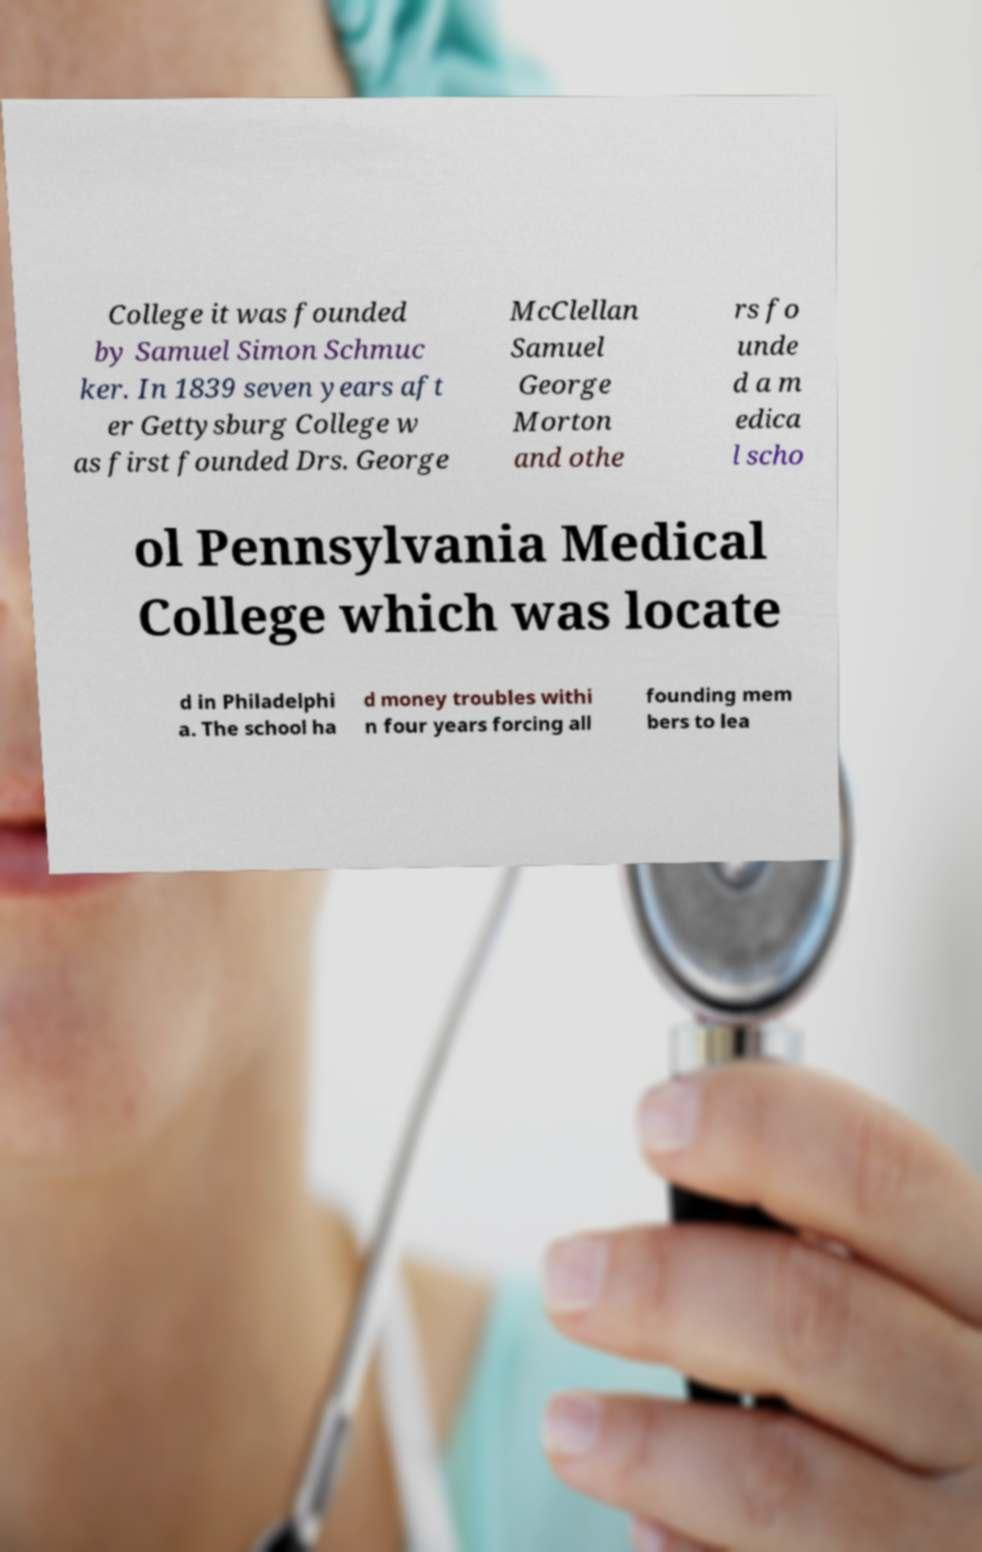Could you extract and type out the text from this image? College it was founded by Samuel Simon Schmuc ker. In 1839 seven years aft er Gettysburg College w as first founded Drs. George McClellan Samuel George Morton and othe rs fo unde d a m edica l scho ol Pennsylvania Medical College which was locate d in Philadelphi a. The school ha d money troubles withi n four years forcing all founding mem bers to lea 